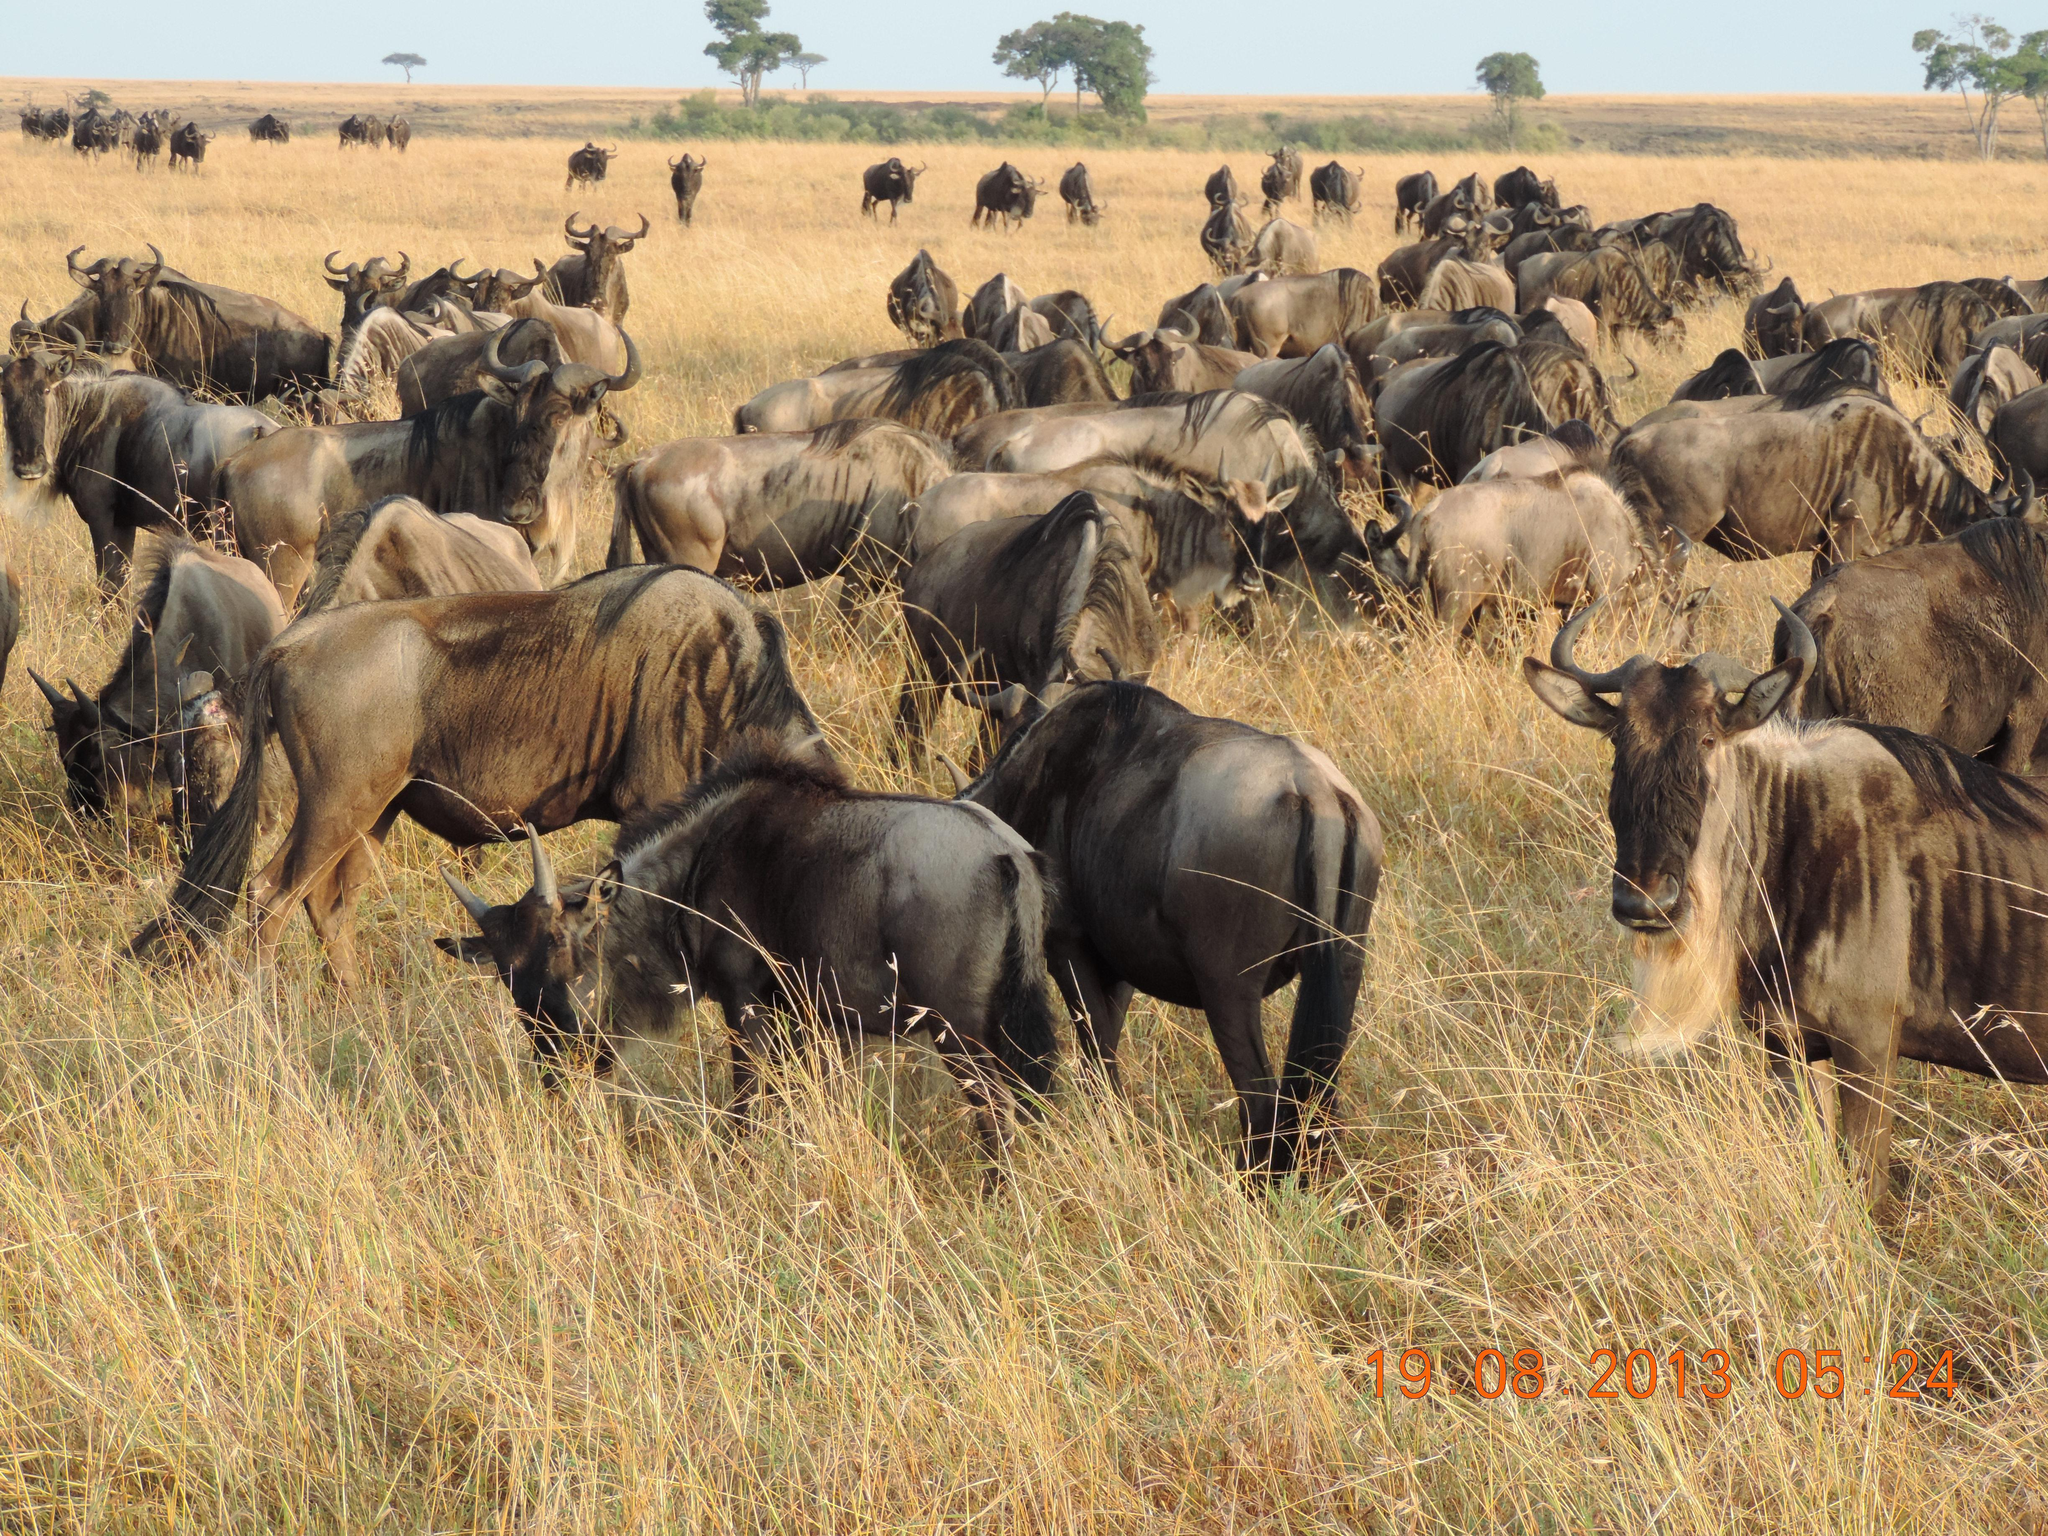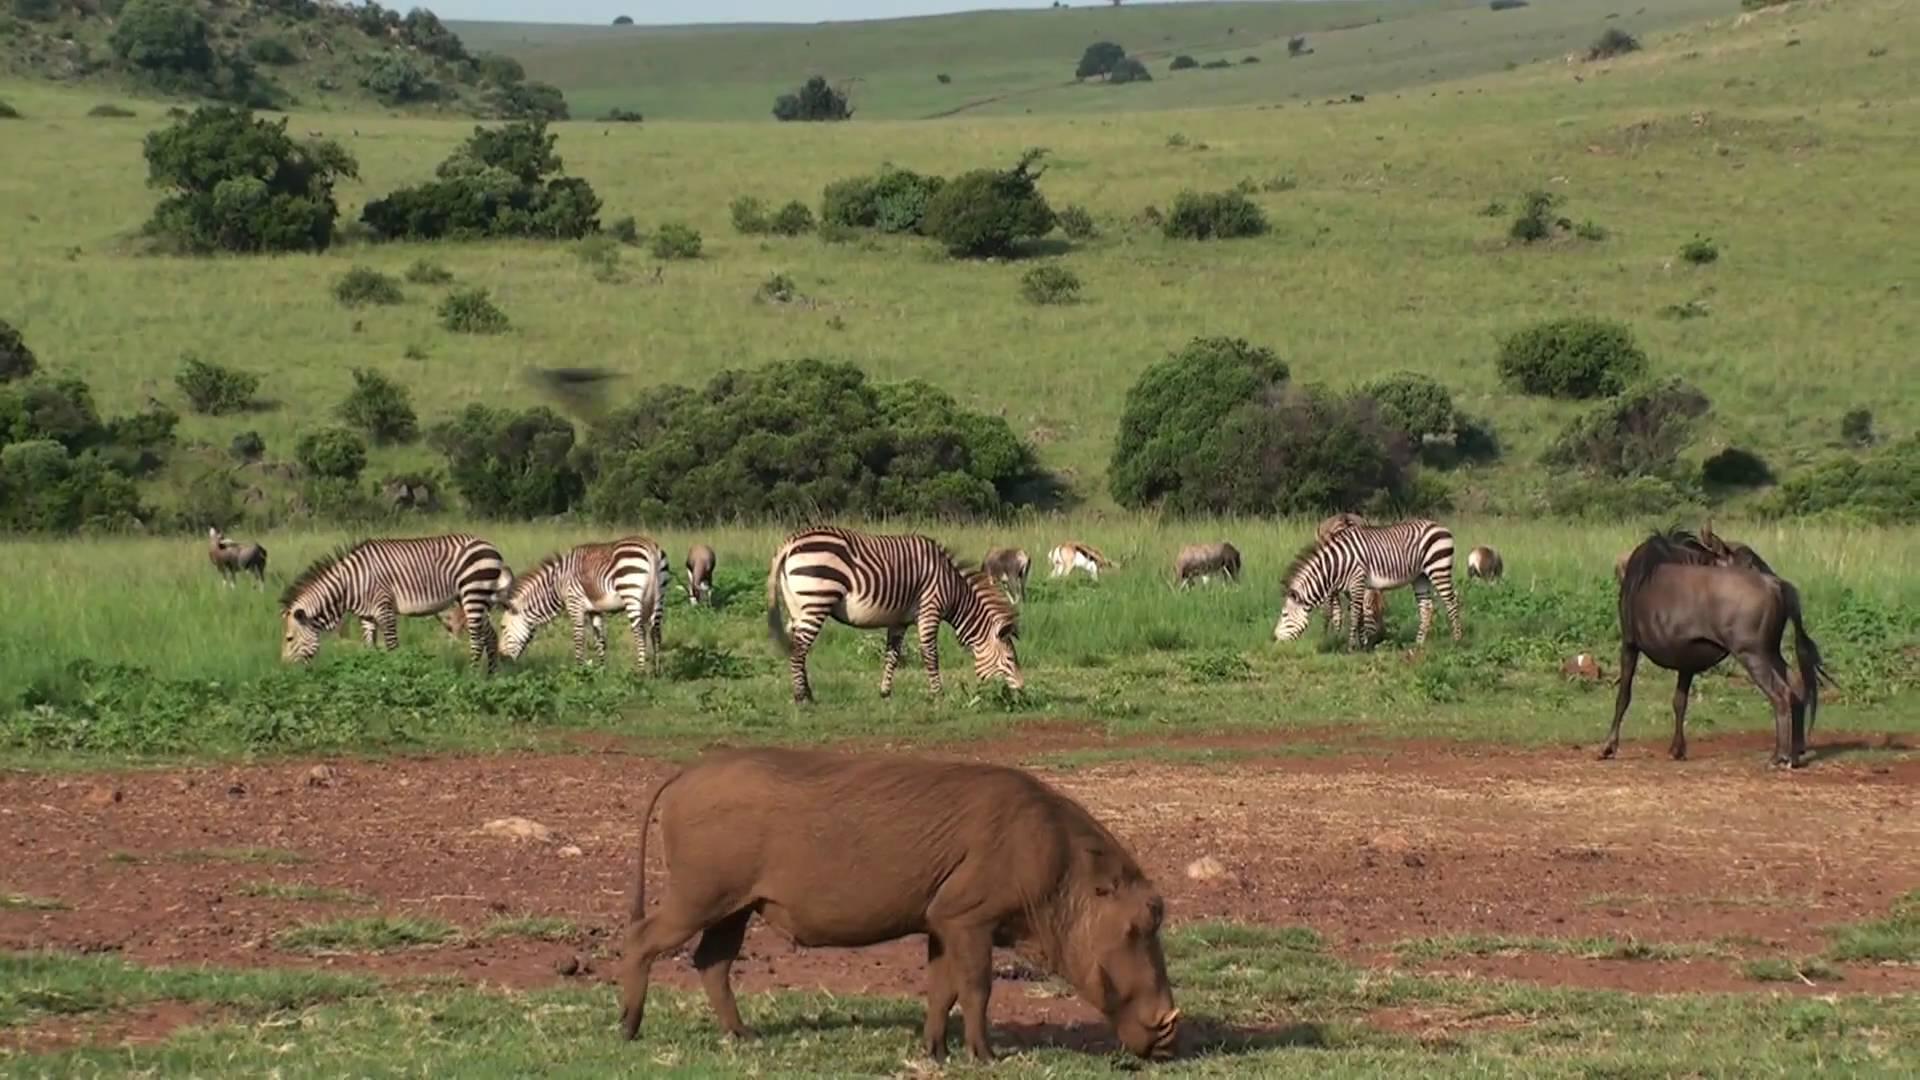The first image is the image on the left, the second image is the image on the right. Examine the images to the left and right. Is the description "An image includes at least five zebra standing on grass behind a patch of dirt." accurate? Answer yes or no. Yes. The first image is the image on the left, the second image is the image on the right. Given the left and right images, does the statement "Some of the animals are near a watery area." hold true? Answer yes or no. No. 